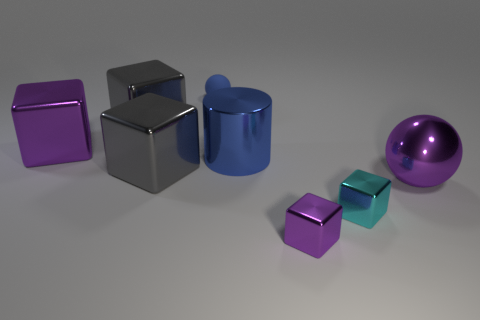Subtract 2 cubes. How many cubes are left? 3 Subtract all cyan cubes. How many cubes are left? 4 Subtract all small purple shiny blocks. How many blocks are left? 4 Add 2 small cyan objects. How many objects exist? 10 Subtract all cyan blocks. Subtract all red cylinders. How many blocks are left? 4 Subtract all cylinders. How many objects are left? 7 Add 1 large metallic cylinders. How many large metallic cylinders are left? 2 Add 8 small metal cubes. How many small metal cubes exist? 10 Subtract 1 purple balls. How many objects are left? 7 Subtract all large purple metallic things. Subtract all blue spheres. How many objects are left? 5 